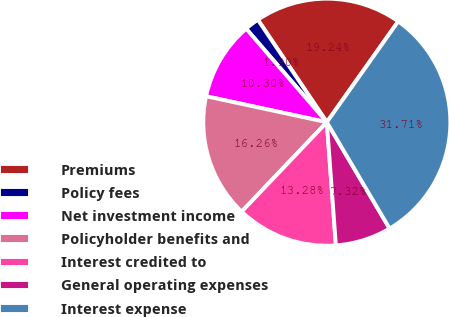Convert chart to OTSL. <chart><loc_0><loc_0><loc_500><loc_500><pie_chart><fcel>Premiums<fcel>Policy fees<fcel>Net investment income<fcel>Policyholder benefits and<fcel>Interest credited to<fcel>General operating expenses<fcel>Interest expense<nl><fcel>19.24%<fcel>1.9%<fcel>10.3%<fcel>16.26%<fcel>13.28%<fcel>7.32%<fcel>31.71%<nl></chart> 